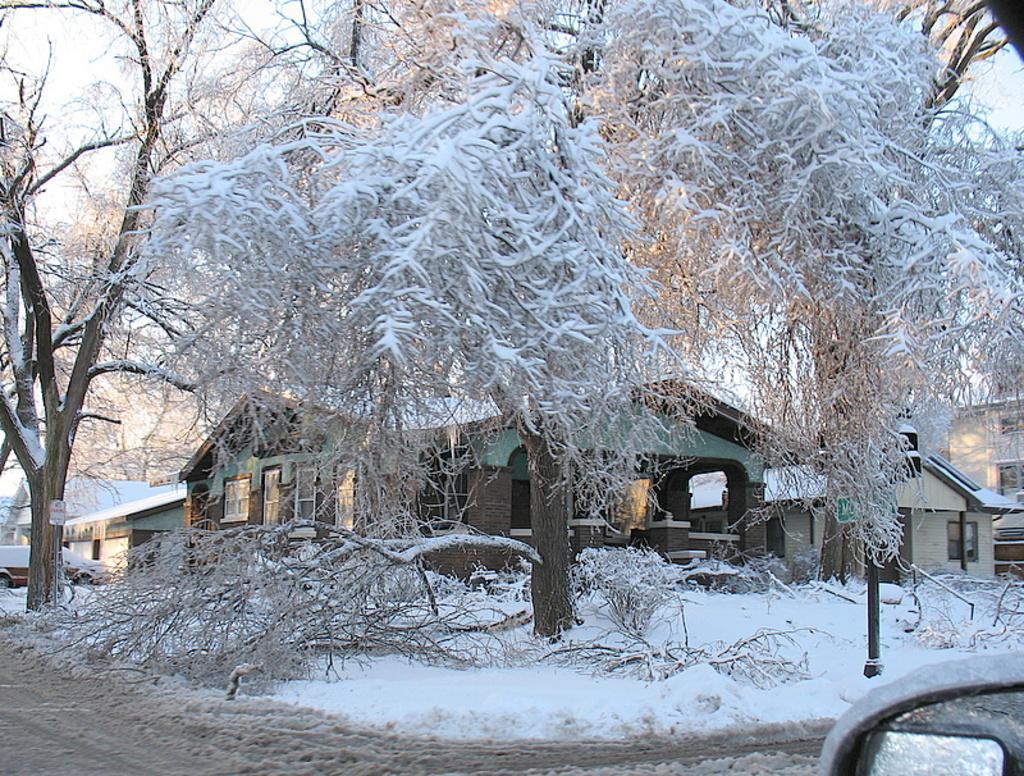Can you describe this image briefly? As we can see in the image there are trees, houses, snow and sky. 